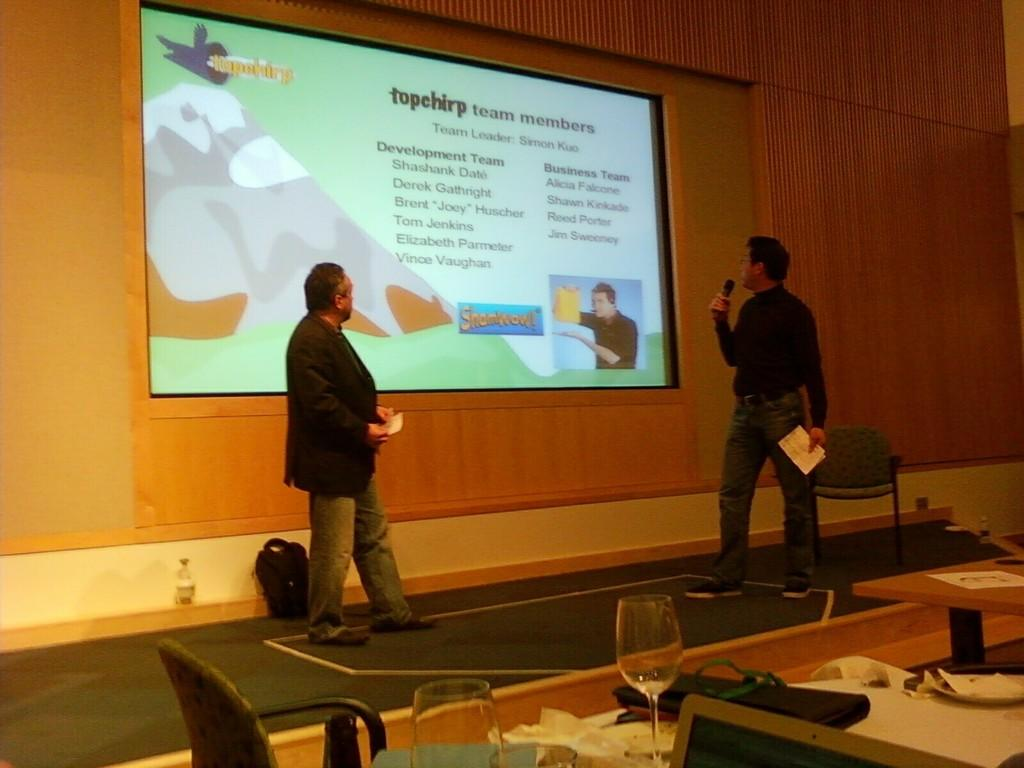How many men are present in the image? There are two men present in the image. What is the second man holding in his hands? The second man is holding a mic and paper in his hands. What objects can be seen on the table in the image? There is a bag, a bottle, a glass, and a plate on the table in the image. What is the purpose of the screen in the image? The purpose of the screen in the image is not specified, but it could be used for displaying information or visuals. What type of creature is sitting on the man's shoulder in the image? There is no creature present on the man's shoulder in the image. 